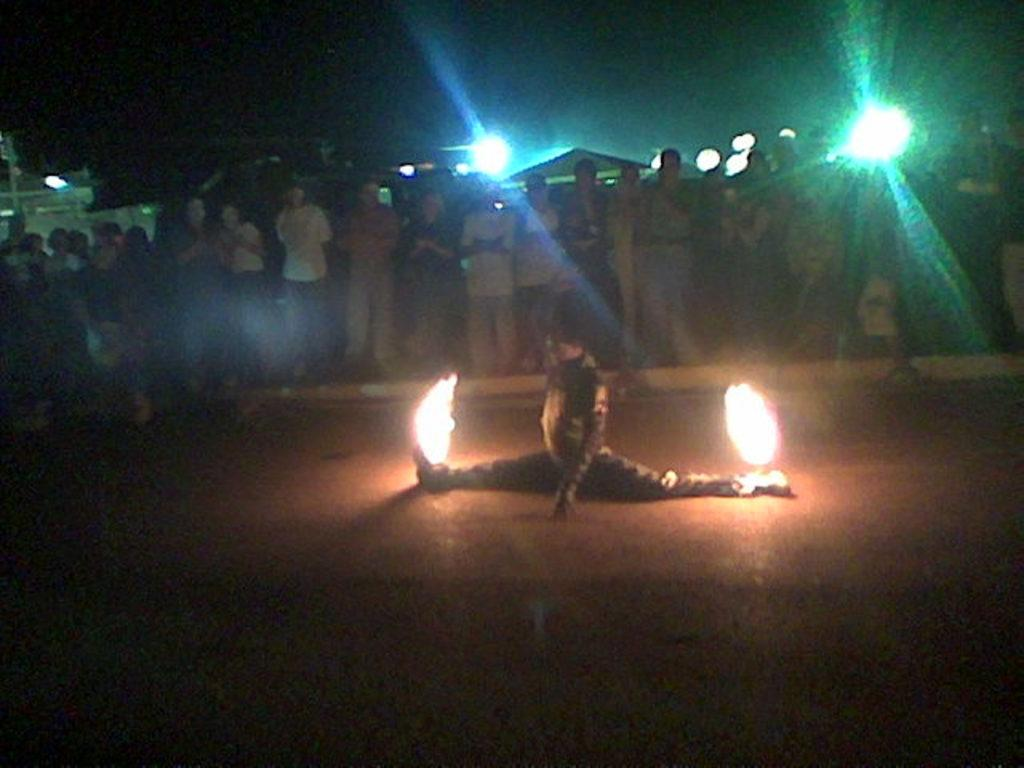What is the main subject of the image? There is a person in the image. How is the person positioned in the image? The person has their legs stretched on the floor. What can be seen in the foreground of the image? There is fire visible in the image. What is visible in the background of the image? There are other persons, lights, and objects in the background of the image. How would you describe the overall appearance of the image? The image has a dark appearance. What type of jam is being sold by the person in the image? There is no jam present in the image, and the person is not selling anything. 